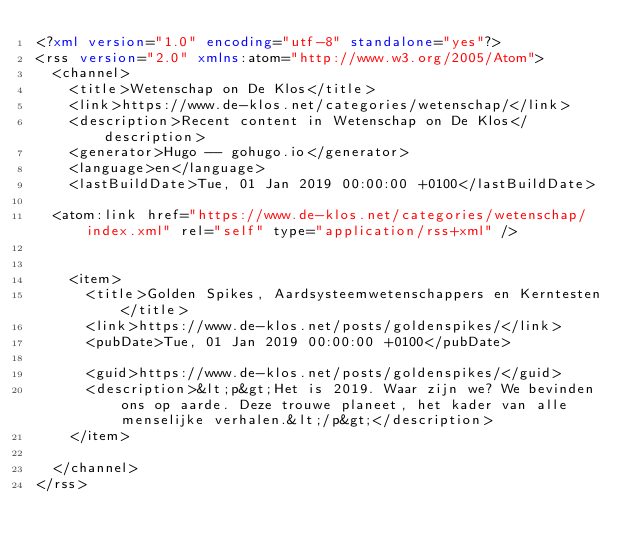<code> <loc_0><loc_0><loc_500><loc_500><_XML_><?xml version="1.0" encoding="utf-8" standalone="yes"?>
<rss version="2.0" xmlns:atom="http://www.w3.org/2005/Atom">
  <channel>
    <title>Wetenschap on De Klos</title>
    <link>https://www.de-klos.net/categories/wetenschap/</link>
    <description>Recent content in Wetenschap on De Klos</description>
    <generator>Hugo -- gohugo.io</generator>
    <language>en</language>
    <lastBuildDate>Tue, 01 Jan 2019 00:00:00 +0100</lastBuildDate>
    
	<atom:link href="https://www.de-klos.net/categories/wetenschap/index.xml" rel="self" type="application/rss+xml" />
    
    
    <item>
      <title>Golden Spikes, Aardsysteemwetenschappers en Kerntesten</title>
      <link>https://www.de-klos.net/posts/goldenspikes/</link>
      <pubDate>Tue, 01 Jan 2019 00:00:00 +0100</pubDate>
      
      <guid>https://www.de-klos.net/posts/goldenspikes/</guid>
      <description>&lt;p&gt;Het is 2019. Waar zijn we? We bevinden ons op aarde. Deze trouwe planeet, het kader van alle menselijke verhalen.&lt;/p&gt;</description>
    </item>
    
  </channel>
</rss></code> 